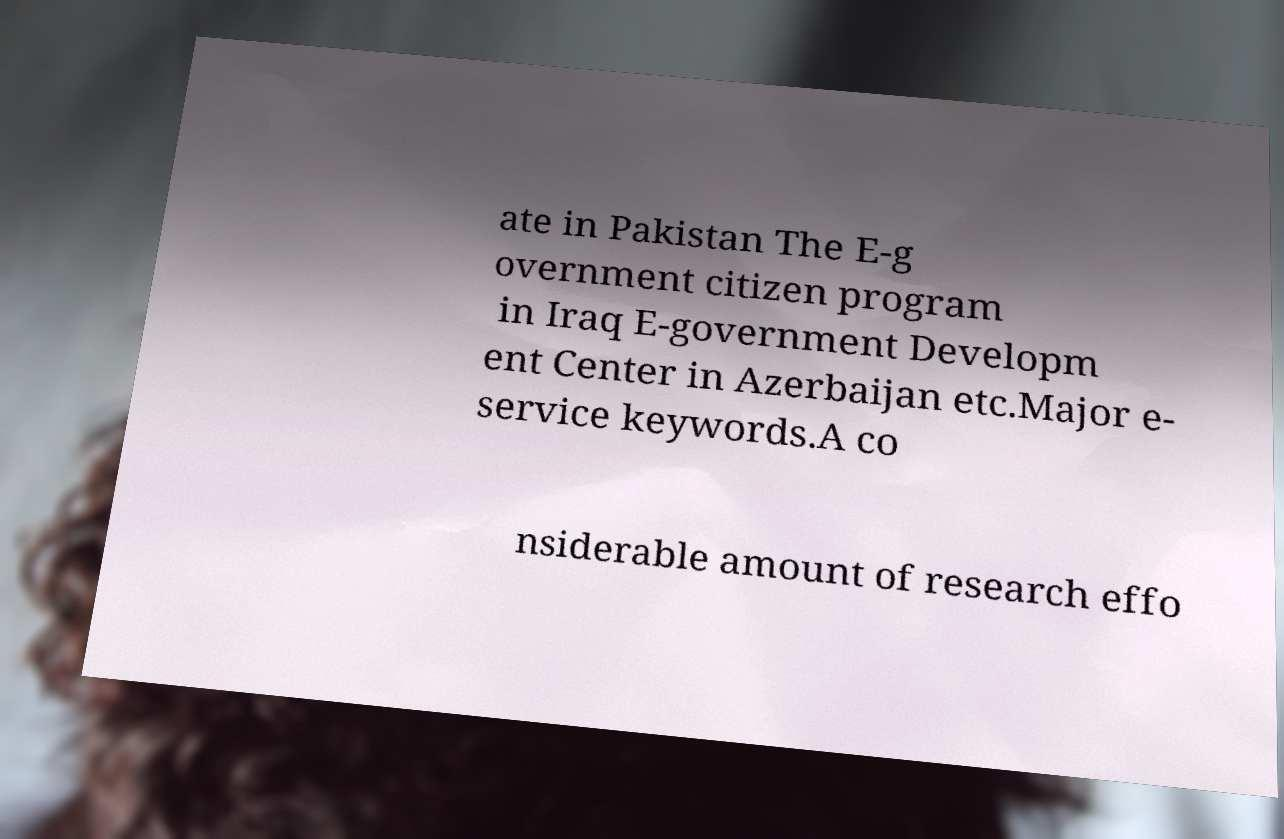Please read and relay the text visible in this image. What does it say? ate in Pakistan The E-g overnment citizen program in Iraq E-government Developm ent Center in Azerbaijan etc.Major e- service keywords.A co nsiderable amount of research effo 